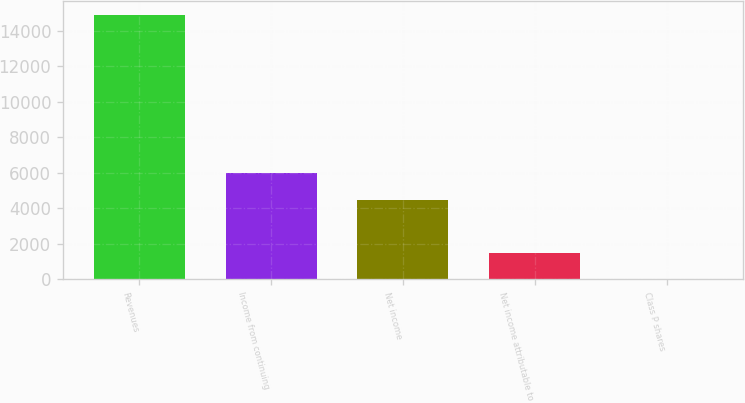Convert chart. <chart><loc_0><loc_0><loc_500><loc_500><bar_chart><fcel>Revenues<fcel>Income from continuing<fcel>Net income<fcel>Net income attributable to<fcel>Class P shares<nl><fcel>14911<fcel>5965.08<fcel>4474.09<fcel>1492.11<fcel>1.12<nl></chart> 